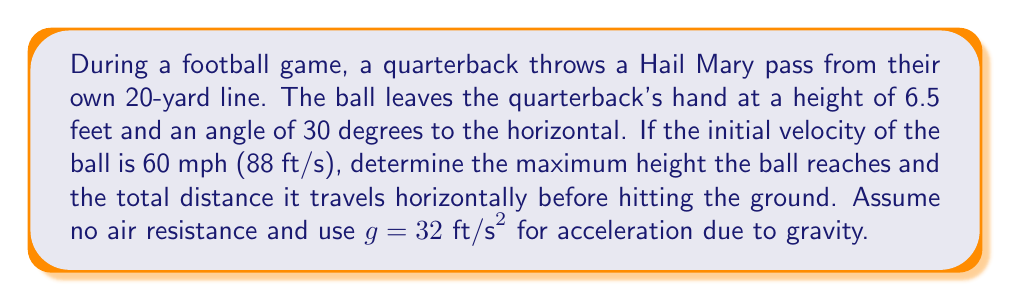Can you answer this question? To solve this problem, we'll use the equations of motion for projectile motion. Let's break it down step-by-step:

1. Convert initial velocity to ft/s:
   60 mph = 88 ft/s

2. Decompose the initial velocity into horizontal and vertical components:
   $v_x = v \cos \theta = 88 \cos 30° = 76.21$ ft/s
   $v_y = v \sin \theta = 88 \sin 30° = 44$ ft/s

3. Time to reach maximum height:
   At the highest point, vertical velocity is zero.
   $$v_y = v_0 - gt$$
   $$0 = 44 - 32t$$
   $$t = \frac{44}{32} = 1.375\text{ s}$$

4. Maximum height:
   Use the equation: $y = y_0 + v_0t - \frac{1}{2}gt^2$
   $$y_{max} = 6.5 + 44(1.375) - \frac{1}{2}(32)(1.375)^2$$
   $$y_{max} = 6.5 + 60.5 - 30.25 = 36.75\text{ ft}$$

5. Total time of flight:
   Use the quadratic equation with $y = 0$:
   $$0 = 6.5 + 44t - 16t^2$$
   $$16t^2 - 44t - 6.5 = 0$$
   $$t = \frac{44 \pm \sqrt{44^2 + 4(16)(6.5)}}{2(16)}$$
   $$t = 2.84\text{ s}$$ (positive root)

6. Horizontal distance:
   $$x = v_x \cdot t = 76.21 \cdot 2.84 = 216.44\text{ ft}$$

Convert to yards: $216.44 \text{ ft} \approx 72.15\text{ yards}$
Answer: The maximum height reached by the ball is 36.75 feet, and the total horizontal distance traveled is approximately 72.15 yards. 